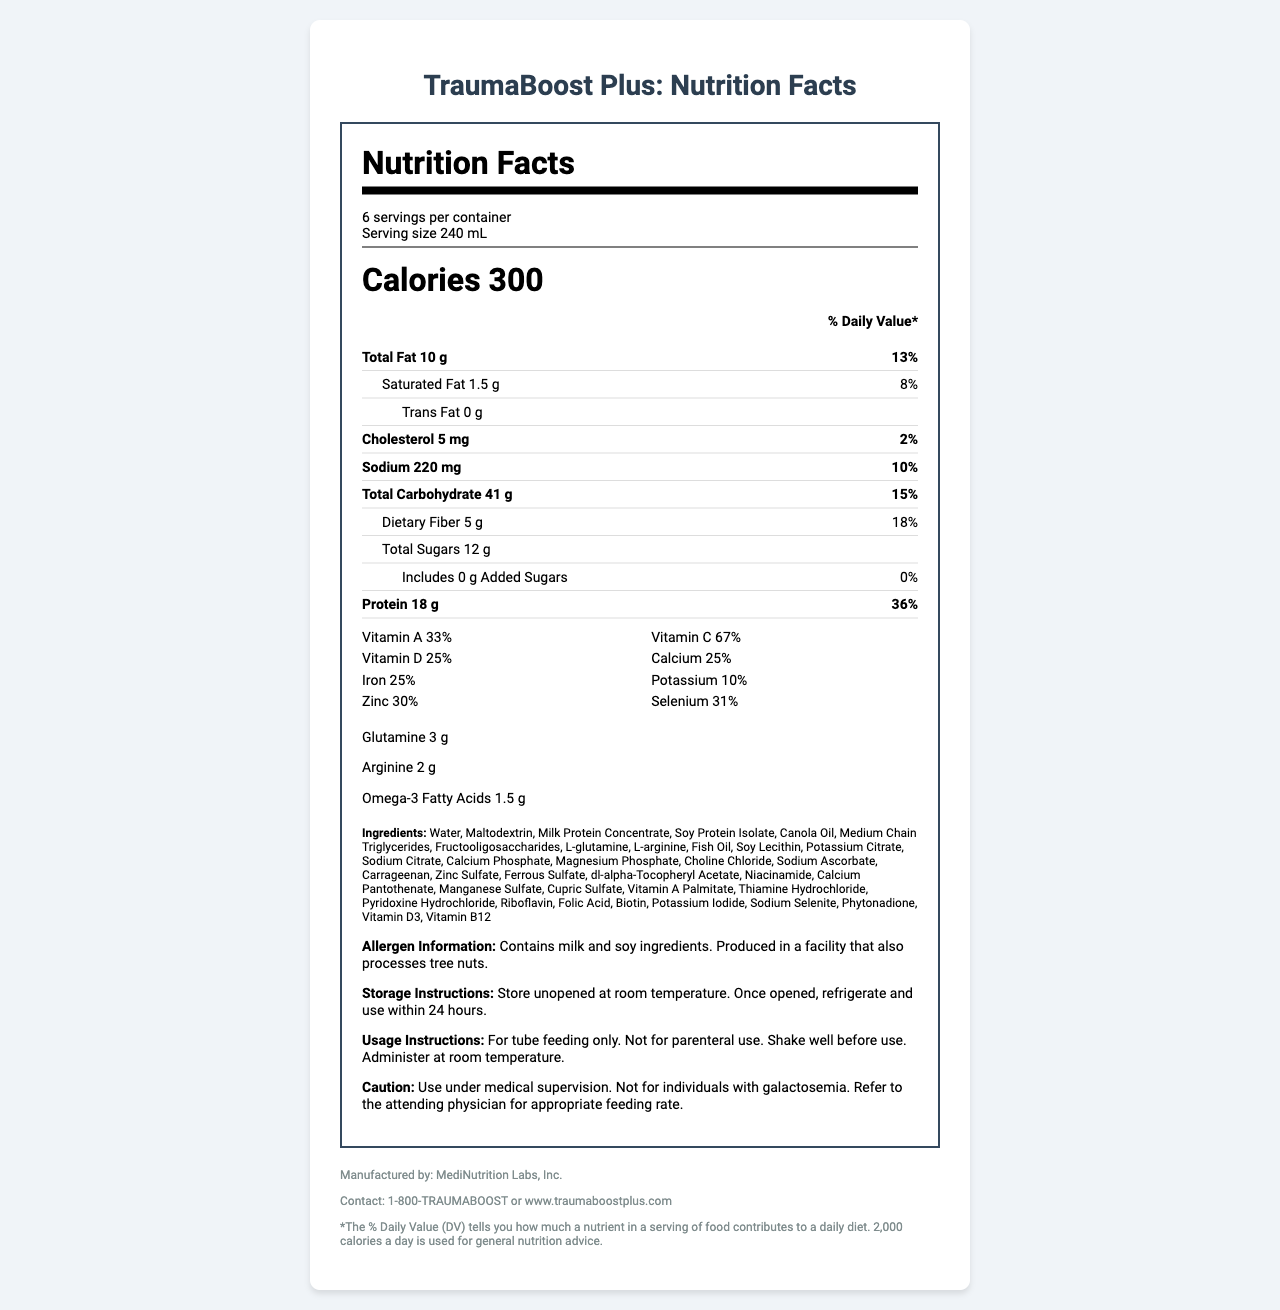Who manufactures TraumaBoost Plus? The document clearly states at the bottom that the manufacturer is MediNutrition Labs, Inc.
Answer: MediNutrition Labs, Inc. What is the serving size of TraumaBoost Plus? The serving size is listed at the top of the nutrition label under the "serving info" section.
Answer: 240 mL How many grams of protein does one serving contain? The protein content per serving is listed on the nutrition facts label as 18 g.
Answer: 18 g Does TraumaBoost Plus contain any trans fats? The nutrition facts clearly state that the product contains 0 g of trans fats.
Answer: No What allergen information is provided? The allergen information section at the bottom of the document lists these details.
Answer: Contains milk and soy ingredients. Produced in a facility that also processes tree nuts. What is the cautionary note mentioned in the document? The caution section provides these specific instructions and warnings.
Answer: Use under medical supervision. Not for individuals with galactosemia. Refer to the attending physician for appropriate feeding rate. What is the percentage daily value of Vitamin C in TraumaBoost Plus? The vitamin section of the nutrition label lists Vitamin C with a 67% daily value.
Answer: 67% Which of the following nutrients is not in TraumaBoost Plus? 1. Calcium, 2. Zinc, 3. Vitamin B6, 4. Vitamin E The detailed nutrient information lists several vitamins and minerals, but Vitamin E (alpha-tocopherol) is not mentioned in the main nutrient section.
Answer: 4. Vitamin E What is the total carbohydrate content per serving? A. 30 g, B. 41 g, C. 25 g, D. 50 g The nutrition facts label lists the total carbohydrate content as 41 g per serving.
Answer: B. 41 g Is TraumaBoost Plus intended for parenteral use? The usage instructions specifically state that the product is for tube feeding only and not for parenteral use.
Answer: No Describe the main idea of the TraumaBoost Plus document. The document provides all necessary details about the nutrient composition, serving information, and special instructions for the product, aimed to assist caregivers and medical professionals in making informed decisions.
Answer: The document is a comprehensive nutrition facts label for TraumaBoost Plus, a fortified enteral feeding solution optimized for post-operative recovery in trauma patients. It includes information on serving size, nutritional content, ingredients, allergen information, and usage instructions. Can TraumaBoost Plus be used for patients with galactosemia? The caution section states that the product is not for individuals with galactosemia.
Answer: No What is the contact information provided for TraumaBoost Plus? The bottom of the document lists this contact information.
Answer: 1-800-TRAUMABOOST or www.traumaboostplus.com Is there any information on the number of calories a day used for general nutrition advice? The document states that 2,000 calories a day is used for general nutrition advice in the footer section.
Answer: Yes How long can you store an opened container of TraumaBoost Plus in the refrigerator? The storage instructions specify that once opened, the product should be refrigerated and used within 24 hours.
Answer: 24 hours What is the exact amount of omega-3 fatty acids in TraumaBoost Plus? The document details that each serving of the product contains 1.5 g of omega-3 fatty acids.
Answer: 1.5 g How much does one container hold in total volume? Each serving is 240 mL, and there are 6 servings per container, leading to a total volume of 1440 mL.
Answer: 1440 mL What is the phone number for MediNutrition Labs, Inc.? The document provides the contact number for TraumaBoost Plus, but not specifically for MediNutrition Labs, Inc.
Answer: Cannot be determined 